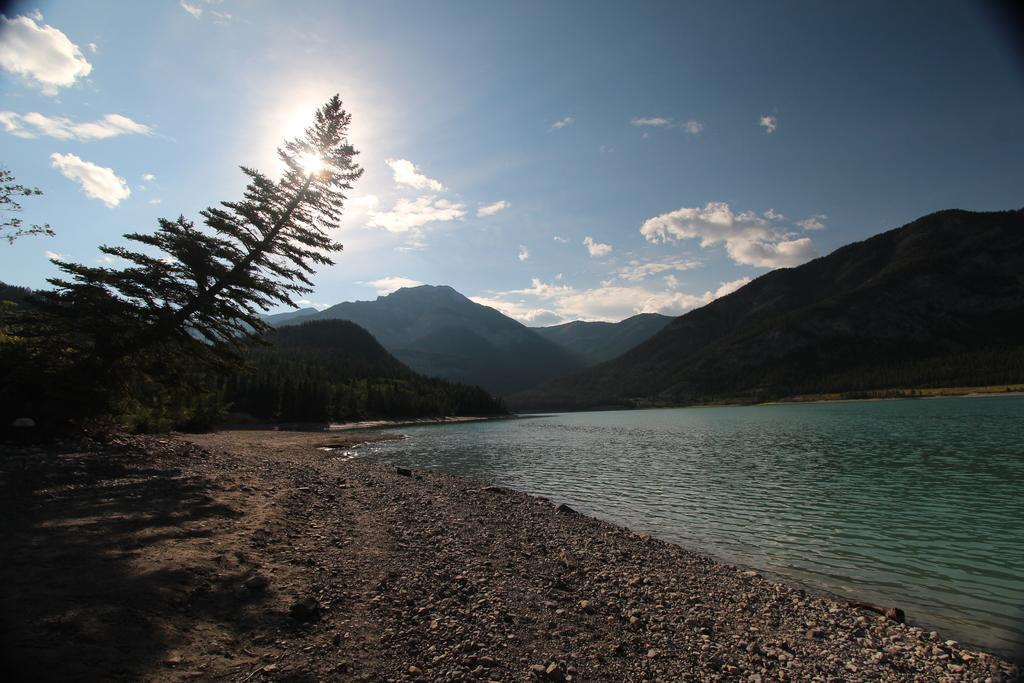What type of location is depicted in the image? The image depicts a seaside location. What is a prominent feature of the foreground in the image? There is a lot of sand in the image. What other natural elements can be seen in the image? There are rocks in the image. What can be seen in the background of the image? There are many trees and mountains visible in the background of the image. What type of advice can be seen written on the rocks in the image? There is no advice written on the rocks in the image; they are just natural elements in the scene. 